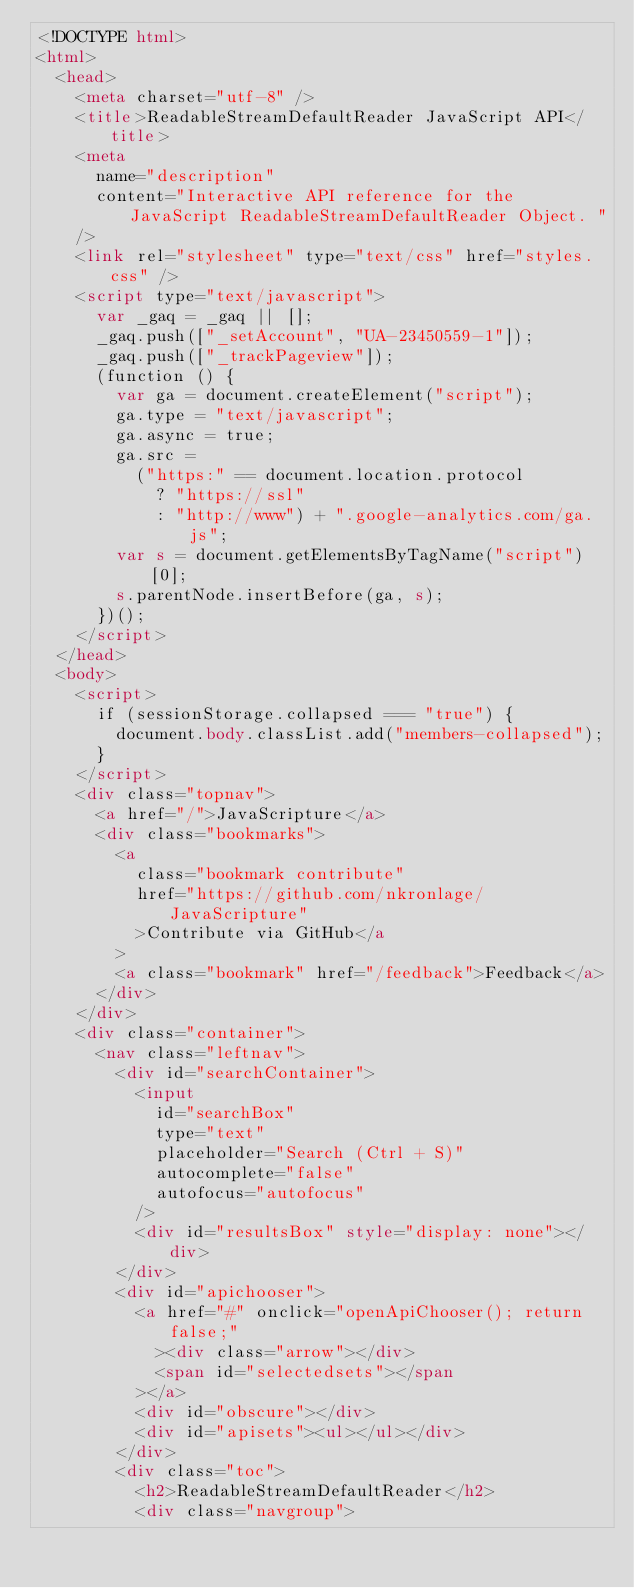Convert code to text. <code><loc_0><loc_0><loc_500><loc_500><_HTML_><!DOCTYPE html>
<html>
  <head>
    <meta charset="utf-8" />
    <title>ReadableStreamDefaultReader JavaScript API</title>
    <meta
      name="description"
      content="Interactive API reference for the JavaScript ReadableStreamDefaultReader Object. "
    />
    <link rel="stylesheet" type="text/css" href="styles.css" />
    <script type="text/javascript">
      var _gaq = _gaq || [];
      _gaq.push(["_setAccount", "UA-23450559-1"]);
      _gaq.push(["_trackPageview"]);
      (function () {
        var ga = document.createElement("script");
        ga.type = "text/javascript";
        ga.async = true;
        ga.src =
          ("https:" == document.location.protocol
            ? "https://ssl"
            : "http://www") + ".google-analytics.com/ga.js";
        var s = document.getElementsByTagName("script")[0];
        s.parentNode.insertBefore(ga, s);
      })();
    </script>
  </head>
  <body>
    <script>
      if (sessionStorage.collapsed === "true") {
        document.body.classList.add("members-collapsed");
      }
    </script>
    <div class="topnav">
      <a href="/">JavaScripture</a>
      <div class="bookmarks">
        <a
          class="bookmark contribute"
          href="https://github.com/nkronlage/JavaScripture"
          >Contribute via GitHub</a
        >
        <a class="bookmark" href="/feedback">Feedback</a>
      </div>
    </div>
    <div class="container">
      <nav class="leftnav">
        <div id="searchContainer">
          <input
            id="searchBox"
            type="text"
            placeholder="Search (Ctrl + S)"
            autocomplete="false"
            autofocus="autofocus"
          />
          <div id="resultsBox" style="display: none"></div>
        </div>
        <div id="apichooser">
          <a href="#" onclick="openApiChooser(); return false;"
            ><div class="arrow"></div>
            <span id="selectedsets"></span
          ></a>
          <div id="obscure"></div>
          <div id="apisets"><ul></ul></div>
        </div>
        <div class="toc">
          <h2>ReadableStreamDefaultReader</h2>
          <div class="navgroup"></code> 